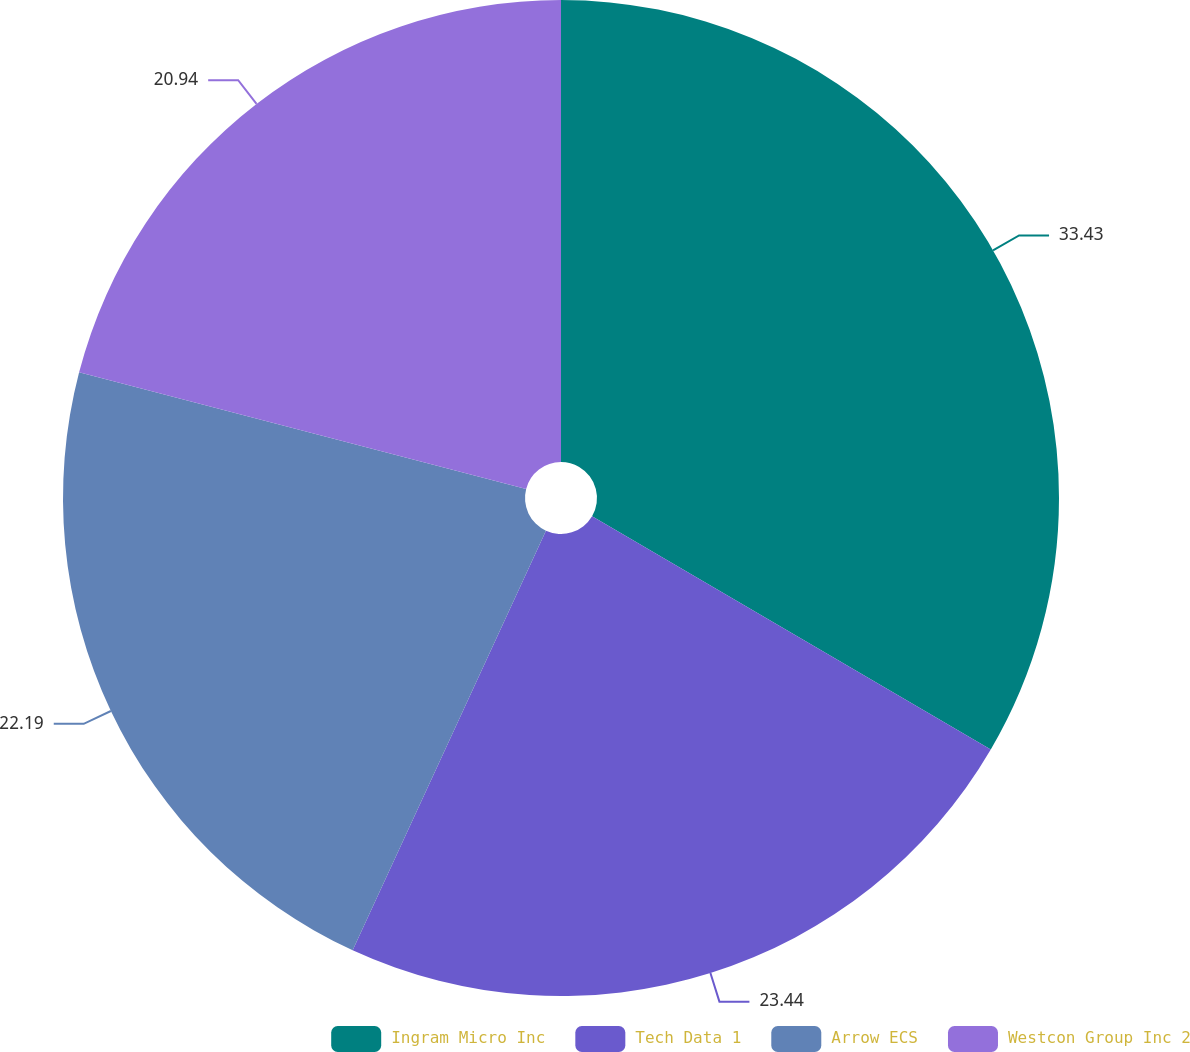Convert chart to OTSL. <chart><loc_0><loc_0><loc_500><loc_500><pie_chart><fcel>Ingram Micro Inc<fcel>Tech Data 1<fcel>Arrow ECS<fcel>Westcon Group Inc 2<nl><fcel>33.43%<fcel>23.44%<fcel>22.19%<fcel>20.94%<nl></chart> 